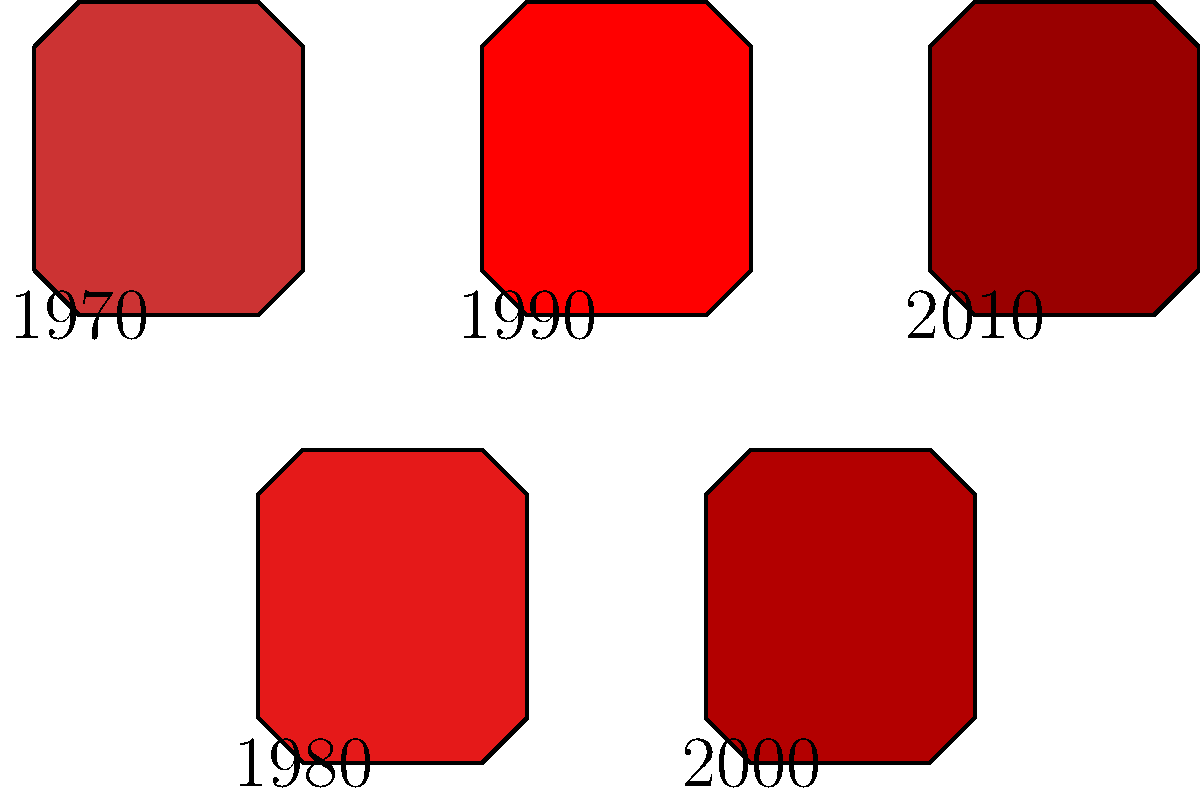As a dedicated football fan, you're presented with a collection of vintage jerseys from your favorite club spanning different eras. The jerseys are labeled with the years 1970, 1980, 1990, 2000, and 2010, each representing a distinct design. How many possible ways are there to arrange these jerseys in chronological order from oldest to newest? To solve this problem, we need to apply the concept of permutations in group theory. Here's a step-by-step explanation:

1. We have 5 distinct jerseys, each from a different year.

2. Since the years are already known (1970, 1980, 1990, 2000, 2010), there is only one correct chronological order.

3. In group theory, when we have a set of n distinct objects and only one correct arrangement, there is only one permutation possible.

4. This is because each jersey has a fixed position in the chronological order, leaving no room for variation.

5. Mathematically, this can be expressed as:

   $$P = 1$$

   Where P represents the number of permutations.

6. In contrast, if the years were unknown and we had to arrange 5 distinct jerseys, we would have used the formula:

   $$P = 5! = 5 \times 4 \times 3 \times 2 \times 1 = 120$$

   But this is not the case in our scenario.

Therefore, there is only one possible way to arrange these jerseys in chronological order from oldest to newest.
Answer: 1 